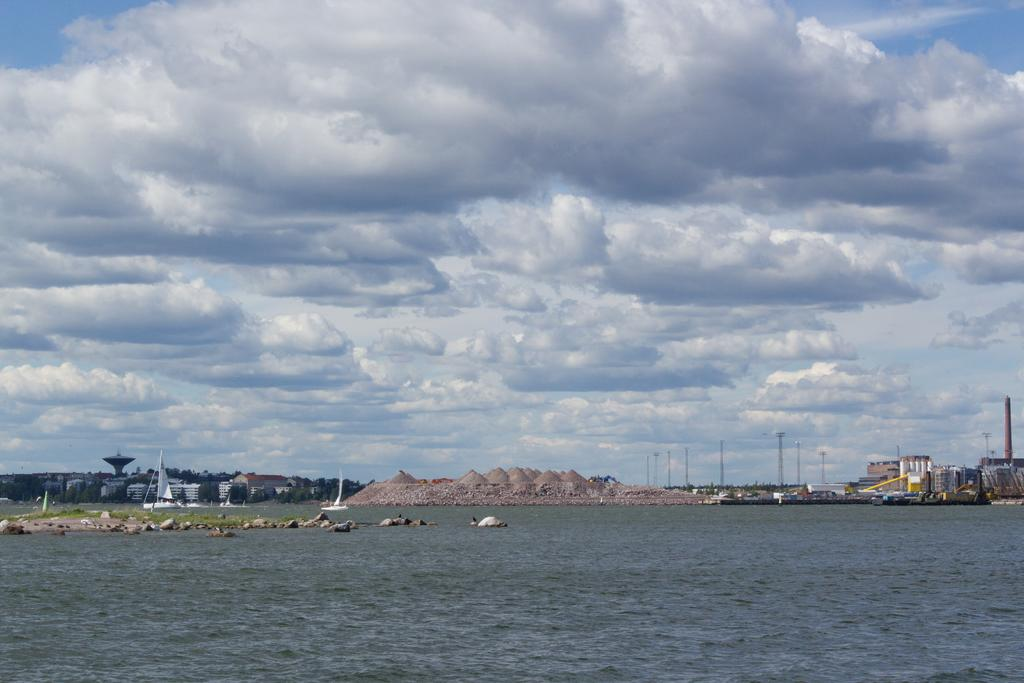What type of structures can be seen in the image? There are buildings in the image. What other objects are present in the image? There are poles, rocks, and other objects in the image. What natural features can be seen in the image? There are mountains in the image. What is visible at the top of the image? The sky is visible at the top of the image. What is present at the bottom of the image? Water is present at the bottom of the image. Where is the door to the mountains located in the image? There is no door to the mountains present in the image. What type of cake can be seen on top of the water in the image? There is no cake present in the image. 